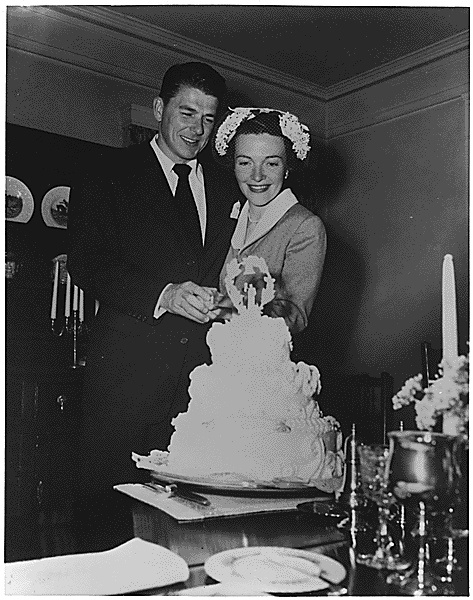Describe the objects in this image and their specific colors. I can see people in white, black, gray, darkgray, and lightgray tones, cake in white, darkgray, gray, black, and lightgray tones, people in white, gray, darkgray, black, and lightgray tones, dining table in white, black, gray, and darkgray tones, and chair in black, gray, darkgray, and white tones in this image. 